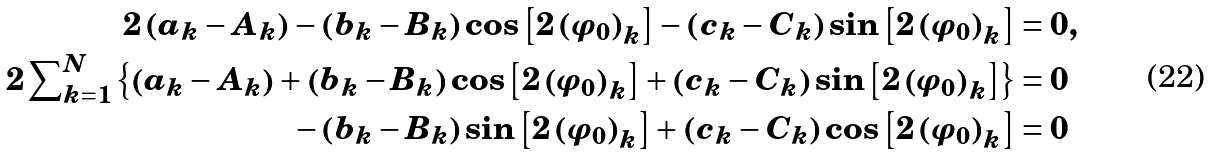Convert formula to latex. <formula><loc_0><loc_0><loc_500><loc_500>2 \left ( a _ { k } - A _ { k } \right ) - \left ( b _ { k } - B _ { k } \right ) \cos \left [ 2 \left ( \varphi _ { 0 } \right ) _ { k } \right ] - \left ( c _ { k } - C _ { k } \right ) \sin \left [ 2 \left ( \varphi _ { 0 } \right ) _ { k } \right ] & = 0 , \\ 2 \sum \nolimits _ { k = 1 } ^ { N } \left \{ \left ( a _ { k } - A _ { k } \right ) + \left ( b _ { k } - B _ { k } \right ) \cos \left [ 2 \left ( \varphi _ { 0 } \right ) _ { k } \right ] + \left ( c _ { k } - C _ { k } \right ) \sin \left [ 2 \left ( \varphi _ { 0 } \right ) _ { k } \right ] \right \} & = 0 \\ - \left ( b _ { k } - B _ { k } \right ) \sin \left [ 2 \left ( \varphi _ { 0 } \right ) _ { k } \right ] + \left ( c _ { k } - C _ { k } \right ) \cos \left [ 2 \left ( \varphi _ { 0 } \right ) _ { k } \right ] & = 0</formula> 